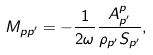<formula> <loc_0><loc_0><loc_500><loc_500>M _ { p p ^ { \prime } } = - \frac { 1 } { 2 \omega } \frac { A _ { p ^ { \prime } } ^ { p } } { \rho _ { p ^ { \prime } } S _ { p ^ { \prime } } } ,</formula> 